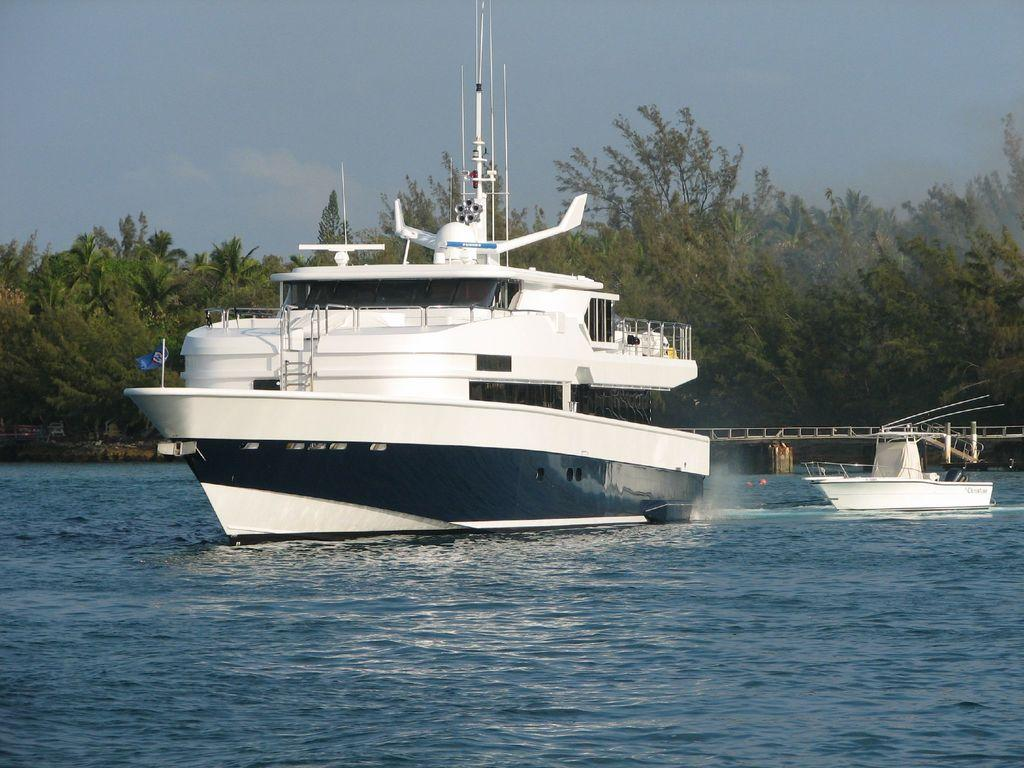What can be seen floating on the water in the image? There are two boats in the water. What structure can be seen in the background of the image? There is a bridge in the background. What type of vegetation is visible in the background of the image? There are trees in the background. What is visible in the sky in the image? There are clouds in the blue sky. What type of music can be heard coming from the boats in the image? There is no indication of music or any sounds coming from the boats in the image. 